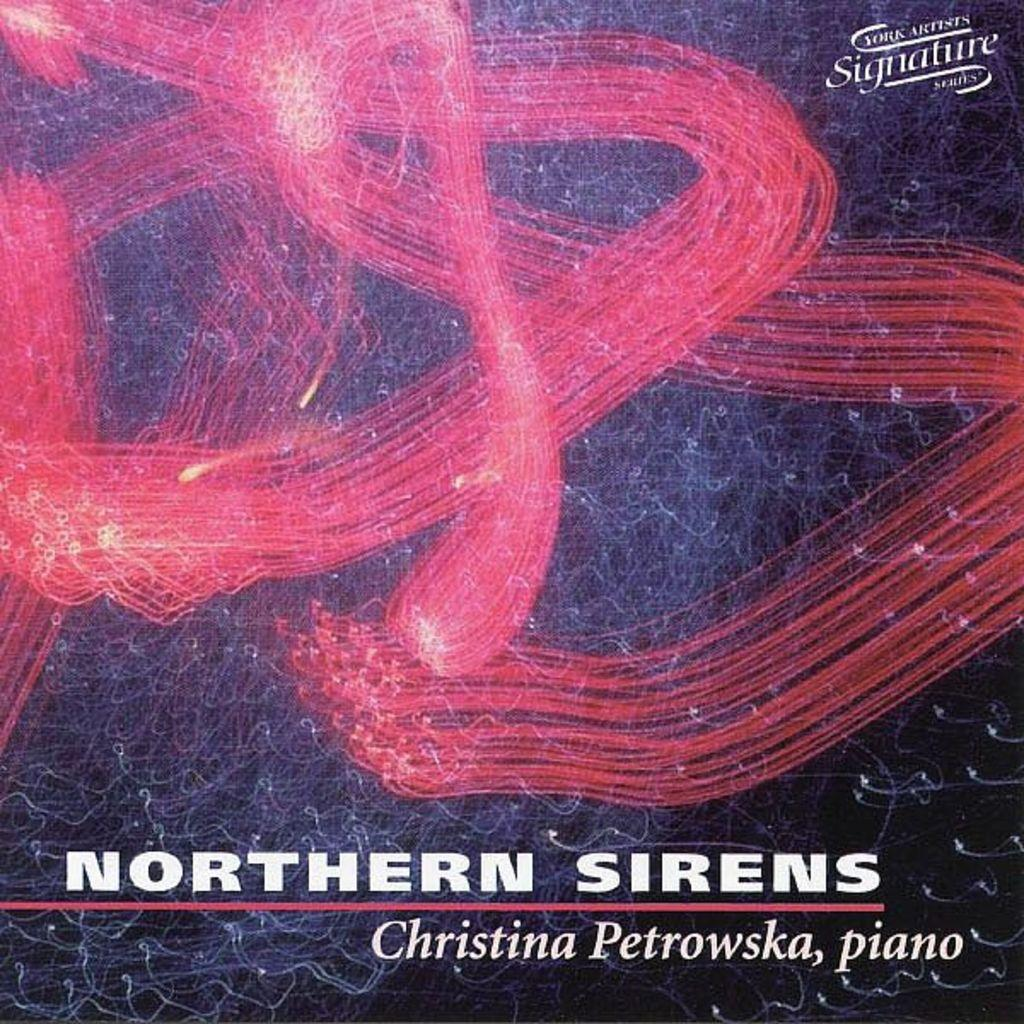Provide a one-sentence caption for the provided image. A book of music by Christina Petrowska on the piano. 